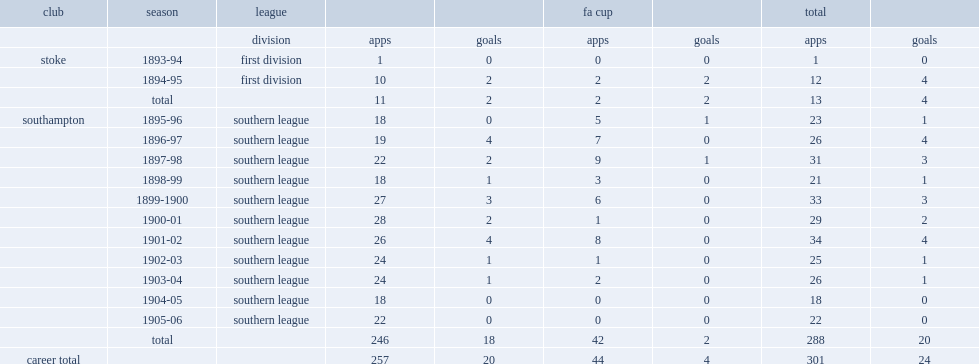What was the total number of appearances made by samuel meston? 288.0. 